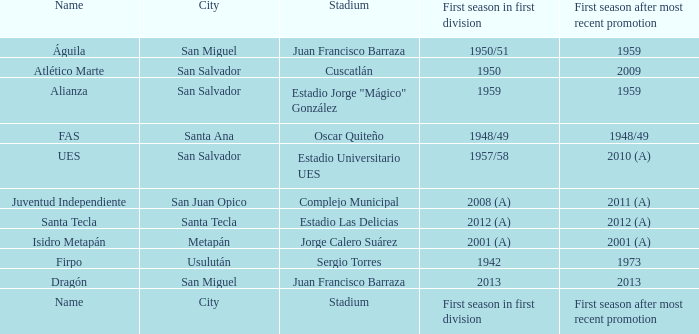When was Alianza's first season in first division with a promotion after 1959? 1959.0. 